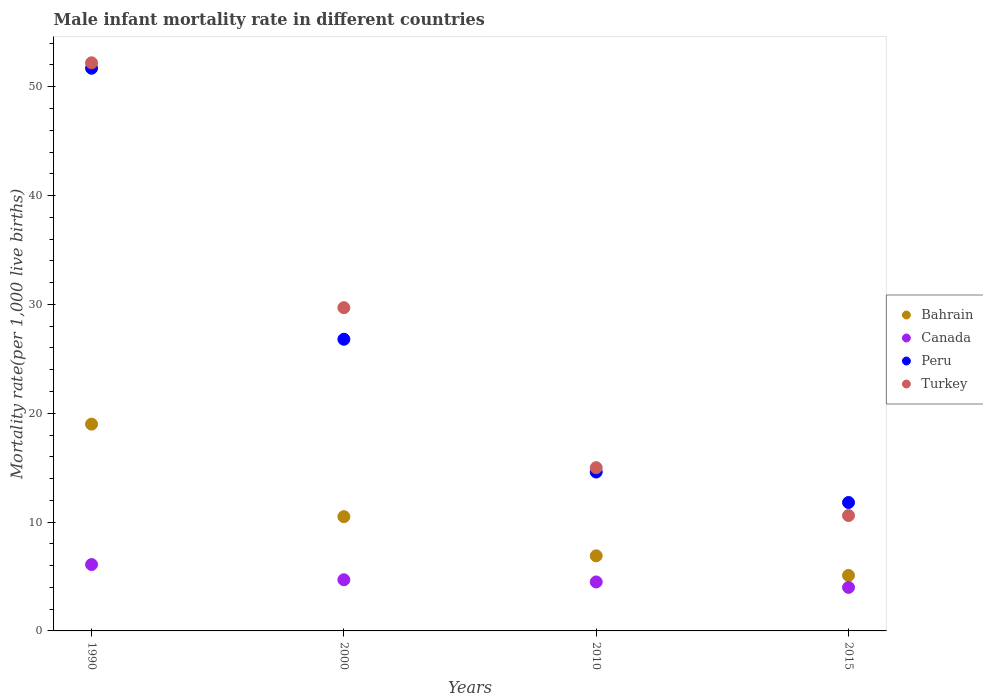How many different coloured dotlines are there?
Your answer should be compact. 4. What is the male infant mortality rate in Bahrain in 1990?
Ensure brevity in your answer.  19. Across all years, what is the maximum male infant mortality rate in Peru?
Offer a terse response. 51.7. Across all years, what is the minimum male infant mortality rate in Peru?
Your response must be concise. 11.8. In which year was the male infant mortality rate in Peru minimum?
Your response must be concise. 2015. What is the total male infant mortality rate in Turkey in the graph?
Make the answer very short. 107.5. What is the difference between the male infant mortality rate in Turkey in 2010 and that in 2015?
Offer a very short reply. 4.4. What is the average male infant mortality rate in Peru per year?
Offer a very short reply. 26.22. In the year 1990, what is the difference between the male infant mortality rate in Canada and male infant mortality rate in Bahrain?
Keep it short and to the point. -12.9. What is the ratio of the male infant mortality rate in Turkey in 1990 to that in 2000?
Ensure brevity in your answer.  1.76. Is the difference between the male infant mortality rate in Canada in 2010 and 2015 greater than the difference between the male infant mortality rate in Bahrain in 2010 and 2015?
Make the answer very short. No. What is the difference between the highest and the second highest male infant mortality rate in Peru?
Keep it short and to the point. 24.9. What is the difference between the highest and the lowest male infant mortality rate in Peru?
Keep it short and to the point. 39.9. Is the sum of the male infant mortality rate in Turkey in 1990 and 2010 greater than the maximum male infant mortality rate in Peru across all years?
Offer a terse response. Yes. Is it the case that in every year, the sum of the male infant mortality rate in Peru and male infant mortality rate in Turkey  is greater than the sum of male infant mortality rate in Bahrain and male infant mortality rate in Canada?
Keep it short and to the point. Yes. Is the male infant mortality rate in Peru strictly greater than the male infant mortality rate in Turkey over the years?
Your answer should be very brief. No. How many years are there in the graph?
Offer a very short reply. 4. What is the difference between two consecutive major ticks on the Y-axis?
Your answer should be very brief. 10. Does the graph contain grids?
Your response must be concise. No. Where does the legend appear in the graph?
Your response must be concise. Center right. How are the legend labels stacked?
Ensure brevity in your answer.  Vertical. What is the title of the graph?
Offer a very short reply. Male infant mortality rate in different countries. What is the label or title of the X-axis?
Provide a succinct answer. Years. What is the label or title of the Y-axis?
Give a very brief answer. Mortality rate(per 1,0 live births). What is the Mortality rate(per 1,000 live births) of Bahrain in 1990?
Provide a short and direct response. 19. What is the Mortality rate(per 1,000 live births) in Canada in 1990?
Keep it short and to the point. 6.1. What is the Mortality rate(per 1,000 live births) in Peru in 1990?
Provide a short and direct response. 51.7. What is the Mortality rate(per 1,000 live births) of Turkey in 1990?
Your answer should be very brief. 52.2. What is the Mortality rate(per 1,000 live births) in Bahrain in 2000?
Your answer should be compact. 10.5. What is the Mortality rate(per 1,000 live births) of Canada in 2000?
Your answer should be very brief. 4.7. What is the Mortality rate(per 1,000 live births) in Peru in 2000?
Your answer should be compact. 26.8. What is the Mortality rate(per 1,000 live births) in Turkey in 2000?
Offer a very short reply. 29.7. What is the Mortality rate(per 1,000 live births) of Bahrain in 2010?
Provide a succinct answer. 6.9. What is the Mortality rate(per 1,000 live births) of Turkey in 2010?
Your answer should be compact. 15. What is the Mortality rate(per 1,000 live births) in Canada in 2015?
Give a very brief answer. 4. What is the Mortality rate(per 1,000 live births) of Peru in 2015?
Make the answer very short. 11.8. What is the Mortality rate(per 1,000 live births) of Turkey in 2015?
Provide a succinct answer. 10.6. Across all years, what is the maximum Mortality rate(per 1,000 live births) of Peru?
Provide a short and direct response. 51.7. Across all years, what is the maximum Mortality rate(per 1,000 live births) in Turkey?
Provide a short and direct response. 52.2. Across all years, what is the minimum Mortality rate(per 1,000 live births) in Canada?
Offer a terse response. 4. Across all years, what is the minimum Mortality rate(per 1,000 live births) in Turkey?
Your answer should be very brief. 10.6. What is the total Mortality rate(per 1,000 live births) of Bahrain in the graph?
Your answer should be very brief. 41.5. What is the total Mortality rate(per 1,000 live births) of Canada in the graph?
Keep it short and to the point. 19.3. What is the total Mortality rate(per 1,000 live births) of Peru in the graph?
Your response must be concise. 104.9. What is the total Mortality rate(per 1,000 live births) of Turkey in the graph?
Offer a terse response. 107.5. What is the difference between the Mortality rate(per 1,000 live births) of Peru in 1990 and that in 2000?
Provide a succinct answer. 24.9. What is the difference between the Mortality rate(per 1,000 live births) in Peru in 1990 and that in 2010?
Your response must be concise. 37.1. What is the difference between the Mortality rate(per 1,000 live births) in Turkey in 1990 and that in 2010?
Your answer should be compact. 37.2. What is the difference between the Mortality rate(per 1,000 live births) in Bahrain in 1990 and that in 2015?
Keep it short and to the point. 13.9. What is the difference between the Mortality rate(per 1,000 live births) in Canada in 1990 and that in 2015?
Offer a very short reply. 2.1. What is the difference between the Mortality rate(per 1,000 live births) of Peru in 1990 and that in 2015?
Ensure brevity in your answer.  39.9. What is the difference between the Mortality rate(per 1,000 live births) in Turkey in 1990 and that in 2015?
Your answer should be very brief. 41.6. What is the difference between the Mortality rate(per 1,000 live births) in Bahrain in 2000 and that in 2010?
Your answer should be very brief. 3.6. What is the difference between the Mortality rate(per 1,000 live births) in Canada in 2000 and that in 2010?
Your answer should be very brief. 0.2. What is the difference between the Mortality rate(per 1,000 live births) in Bahrain in 2000 and that in 2015?
Keep it short and to the point. 5.4. What is the difference between the Mortality rate(per 1,000 live births) in Peru in 2000 and that in 2015?
Your response must be concise. 15. What is the difference between the Mortality rate(per 1,000 live births) in Bahrain in 2010 and that in 2015?
Keep it short and to the point. 1.8. What is the difference between the Mortality rate(per 1,000 live births) of Canada in 2010 and that in 2015?
Make the answer very short. 0.5. What is the difference between the Mortality rate(per 1,000 live births) of Peru in 2010 and that in 2015?
Offer a very short reply. 2.8. What is the difference between the Mortality rate(per 1,000 live births) in Turkey in 2010 and that in 2015?
Provide a short and direct response. 4.4. What is the difference between the Mortality rate(per 1,000 live births) in Bahrain in 1990 and the Mortality rate(per 1,000 live births) in Canada in 2000?
Your answer should be very brief. 14.3. What is the difference between the Mortality rate(per 1,000 live births) in Canada in 1990 and the Mortality rate(per 1,000 live births) in Peru in 2000?
Provide a short and direct response. -20.7. What is the difference between the Mortality rate(per 1,000 live births) in Canada in 1990 and the Mortality rate(per 1,000 live births) in Turkey in 2000?
Your answer should be very brief. -23.6. What is the difference between the Mortality rate(per 1,000 live births) of Peru in 1990 and the Mortality rate(per 1,000 live births) of Turkey in 2000?
Offer a very short reply. 22. What is the difference between the Mortality rate(per 1,000 live births) of Bahrain in 1990 and the Mortality rate(per 1,000 live births) of Peru in 2010?
Provide a short and direct response. 4.4. What is the difference between the Mortality rate(per 1,000 live births) in Canada in 1990 and the Mortality rate(per 1,000 live births) in Peru in 2010?
Your answer should be compact. -8.5. What is the difference between the Mortality rate(per 1,000 live births) of Peru in 1990 and the Mortality rate(per 1,000 live births) of Turkey in 2010?
Offer a terse response. 36.7. What is the difference between the Mortality rate(per 1,000 live births) of Bahrain in 1990 and the Mortality rate(per 1,000 live births) of Peru in 2015?
Make the answer very short. 7.2. What is the difference between the Mortality rate(per 1,000 live births) in Bahrain in 1990 and the Mortality rate(per 1,000 live births) in Turkey in 2015?
Offer a terse response. 8.4. What is the difference between the Mortality rate(per 1,000 live births) in Canada in 1990 and the Mortality rate(per 1,000 live births) in Turkey in 2015?
Your answer should be very brief. -4.5. What is the difference between the Mortality rate(per 1,000 live births) in Peru in 1990 and the Mortality rate(per 1,000 live births) in Turkey in 2015?
Provide a succinct answer. 41.1. What is the difference between the Mortality rate(per 1,000 live births) of Bahrain in 2000 and the Mortality rate(per 1,000 live births) of Canada in 2010?
Provide a short and direct response. 6. What is the difference between the Mortality rate(per 1,000 live births) of Bahrain in 2000 and the Mortality rate(per 1,000 live births) of Peru in 2010?
Your answer should be compact. -4.1. What is the difference between the Mortality rate(per 1,000 live births) of Canada in 2000 and the Mortality rate(per 1,000 live births) of Peru in 2010?
Your response must be concise. -9.9. What is the difference between the Mortality rate(per 1,000 live births) in Peru in 2000 and the Mortality rate(per 1,000 live births) in Turkey in 2010?
Your answer should be very brief. 11.8. What is the difference between the Mortality rate(per 1,000 live births) in Bahrain in 2000 and the Mortality rate(per 1,000 live births) in Canada in 2015?
Make the answer very short. 6.5. What is the difference between the Mortality rate(per 1,000 live births) in Bahrain in 2000 and the Mortality rate(per 1,000 live births) in Peru in 2015?
Your response must be concise. -1.3. What is the difference between the Mortality rate(per 1,000 live births) in Peru in 2000 and the Mortality rate(per 1,000 live births) in Turkey in 2015?
Your response must be concise. 16.2. What is the difference between the Mortality rate(per 1,000 live births) of Bahrain in 2010 and the Mortality rate(per 1,000 live births) of Canada in 2015?
Ensure brevity in your answer.  2.9. What is the difference between the Mortality rate(per 1,000 live births) in Bahrain in 2010 and the Mortality rate(per 1,000 live births) in Peru in 2015?
Make the answer very short. -4.9. What is the difference between the Mortality rate(per 1,000 live births) in Bahrain in 2010 and the Mortality rate(per 1,000 live births) in Turkey in 2015?
Offer a terse response. -3.7. What is the difference between the Mortality rate(per 1,000 live births) of Peru in 2010 and the Mortality rate(per 1,000 live births) of Turkey in 2015?
Keep it short and to the point. 4. What is the average Mortality rate(per 1,000 live births) of Bahrain per year?
Keep it short and to the point. 10.38. What is the average Mortality rate(per 1,000 live births) in Canada per year?
Provide a succinct answer. 4.83. What is the average Mortality rate(per 1,000 live births) in Peru per year?
Provide a short and direct response. 26.23. What is the average Mortality rate(per 1,000 live births) in Turkey per year?
Ensure brevity in your answer.  26.88. In the year 1990, what is the difference between the Mortality rate(per 1,000 live births) in Bahrain and Mortality rate(per 1,000 live births) in Peru?
Your answer should be very brief. -32.7. In the year 1990, what is the difference between the Mortality rate(per 1,000 live births) in Bahrain and Mortality rate(per 1,000 live births) in Turkey?
Ensure brevity in your answer.  -33.2. In the year 1990, what is the difference between the Mortality rate(per 1,000 live births) of Canada and Mortality rate(per 1,000 live births) of Peru?
Your answer should be compact. -45.6. In the year 1990, what is the difference between the Mortality rate(per 1,000 live births) of Canada and Mortality rate(per 1,000 live births) of Turkey?
Offer a very short reply. -46.1. In the year 2000, what is the difference between the Mortality rate(per 1,000 live births) in Bahrain and Mortality rate(per 1,000 live births) in Canada?
Ensure brevity in your answer.  5.8. In the year 2000, what is the difference between the Mortality rate(per 1,000 live births) in Bahrain and Mortality rate(per 1,000 live births) in Peru?
Offer a very short reply. -16.3. In the year 2000, what is the difference between the Mortality rate(per 1,000 live births) in Bahrain and Mortality rate(per 1,000 live births) in Turkey?
Provide a short and direct response. -19.2. In the year 2000, what is the difference between the Mortality rate(per 1,000 live births) of Canada and Mortality rate(per 1,000 live births) of Peru?
Your answer should be compact. -22.1. In the year 2000, what is the difference between the Mortality rate(per 1,000 live births) of Canada and Mortality rate(per 1,000 live births) of Turkey?
Ensure brevity in your answer.  -25. In the year 2010, what is the difference between the Mortality rate(per 1,000 live births) in Bahrain and Mortality rate(per 1,000 live births) in Canada?
Provide a succinct answer. 2.4. In the year 2010, what is the difference between the Mortality rate(per 1,000 live births) of Bahrain and Mortality rate(per 1,000 live births) of Turkey?
Make the answer very short. -8.1. In the year 2010, what is the difference between the Mortality rate(per 1,000 live births) in Peru and Mortality rate(per 1,000 live births) in Turkey?
Make the answer very short. -0.4. In the year 2015, what is the difference between the Mortality rate(per 1,000 live births) in Bahrain and Mortality rate(per 1,000 live births) in Canada?
Offer a terse response. 1.1. In the year 2015, what is the difference between the Mortality rate(per 1,000 live births) in Bahrain and Mortality rate(per 1,000 live births) in Peru?
Make the answer very short. -6.7. In the year 2015, what is the difference between the Mortality rate(per 1,000 live births) of Peru and Mortality rate(per 1,000 live births) of Turkey?
Provide a short and direct response. 1.2. What is the ratio of the Mortality rate(per 1,000 live births) in Bahrain in 1990 to that in 2000?
Offer a very short reply. 1.81. What is the ratio of the Mortality rate(per 1,000 live births) of Canada in 1990 to that in 2000?
Your response must be concise. 1.3. What is the ratio of the Mortality rate(per 1,000 live births) of Peru in 1990 to that in 2000?
Your answer should be compact. 1.93. What is the ratio of the Mortality rate(per 1,000 live births) of Turkey in 1990 to that in 2000?
Provide a succinct answer. 1.76. What is the ratio of the Mortality rate(per 1,000 live births) of Bahrain in 1990 to that in 2010?
Offer a terse response. 2.75. What is the ratio of the Mortality rate(per 1,000 live births) of Canada in 1990 to that in 2010?
Provide a succinct answer. 1.36. What is the ratio of the Mortality rate(per 1,000 live births) of Peru in 1990 to that in 2010?
Offer a very short reply. 3.54. What is the ratio of the Mortality rate(per 1,000 live births) in Turkey in 1990 to that in 2010?
Your answer should be compact. 3.48. What is the ratio of the Mortality rate(per 1,000 live births) in Bahrain in 1990 to that in 2015?
Provide a succinct answer. 3.73. What is the ratio of the Mortality rate(per 1,000 live births) of Canada in 1990 to that in 2015?
Your answer should be very brief. 1.52. What is the ratio of the Mortality rate(per 1,000 live births) in Peru in 1990 to that in 2015?
Your response must be concise. 4.38. What is the ratio of the Mortality rate(per 1,000 live births) of Turkey in 1990 to that in 2015?
Your answer should be compact. 4.92. What is the ratio of the Mortality rate(per 1,000 live births) of Bahrain in 2000 to that in 2010?
Provide a short and direct response. 1.52. What is the ratio of the Mortality rate(per 1,000 live births) in Canada in 2000 to that in 2010?
Give a very brief answer. 1.04. What is the ratio of the Mortality rate(per 1,000 live births) in Peru in 2000 to that in 2010?
Your answer should be compact. 1.84. What is the ratio of the Mortality rate(per 1,000 live births) of Turkey in 2000 to that in 2010?
Make the answer very short. 1.98. What is the ratio of the Mortality rate(per 1,000 live births) in Bahrain in 2000 to that in 2015?
Keep it short and to the point. 2.06. What is the ratio of the Mortality rate(per 1,000 live births) of Canada in 2000 to that in 2015?
Offer a very short reply. 1.18. What is the ratio of the Mortality rate(per 1,000 live births) of Peru in 2000 to that in 2015?
Ensure brevity in your answer.  2.27. What is the ratio of the Mortality rate(per 1,000 live births) of Turkey in 2000 to that in 2015?
Your answer should be very brief. 2.8. What is the ratio of the Mortality rate(per 1,000 live births) in Bahrain in 2010 to that in 2015?
Give a very brief answer. 1.35. What is the ratio of the Mortality rate(per 1,000 live births) in Canada in 2010 to that in 2015?
Your answer should be very brief. 1.12. What is the ratio of the Mortality rate(per 1,000 live births) of Peru in 2010 to that in 2015?
Your response must be concise. 1.24. What is the ratio of the Mortality rate(per 1,000 live births) of Turkey in 2010 to that in 2015?
Offer a terse response. 1.42. What is the difference between the highest and the second highest Mortality rate(per 1,000 live births) in Bahrain?
Keep it short and to the point. 8.5. What is the difference between the highest and the second highest Mortality rate(per 1,000 live births) of Peru?
Make the answer very short. 24.9. What is the difference between the highest and the second highest Mortality rate(per 1,000 live births) in Turkey?
Your answer should be compact. 22.5. What is the difference between the highest and the lowest Mortality rate(per 1,000 live births) of Bahrain?
Provide a short and direct response. 13.9. What is the difference between the highest and the lowest Mortality rate(per 1,000 live births) in Canada?
Offer a terse response. 2.1. What is the difference between the highest and the lowest Mortality rate(per 1,000 live births) of Peru?
Your answer should be compact. 39.9. What is the difference between the highest and the lowest Mortality rate(per 1,000 live births) in Turkey?
Your answer should be compact. 41.6. 